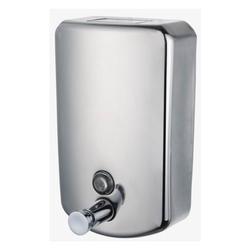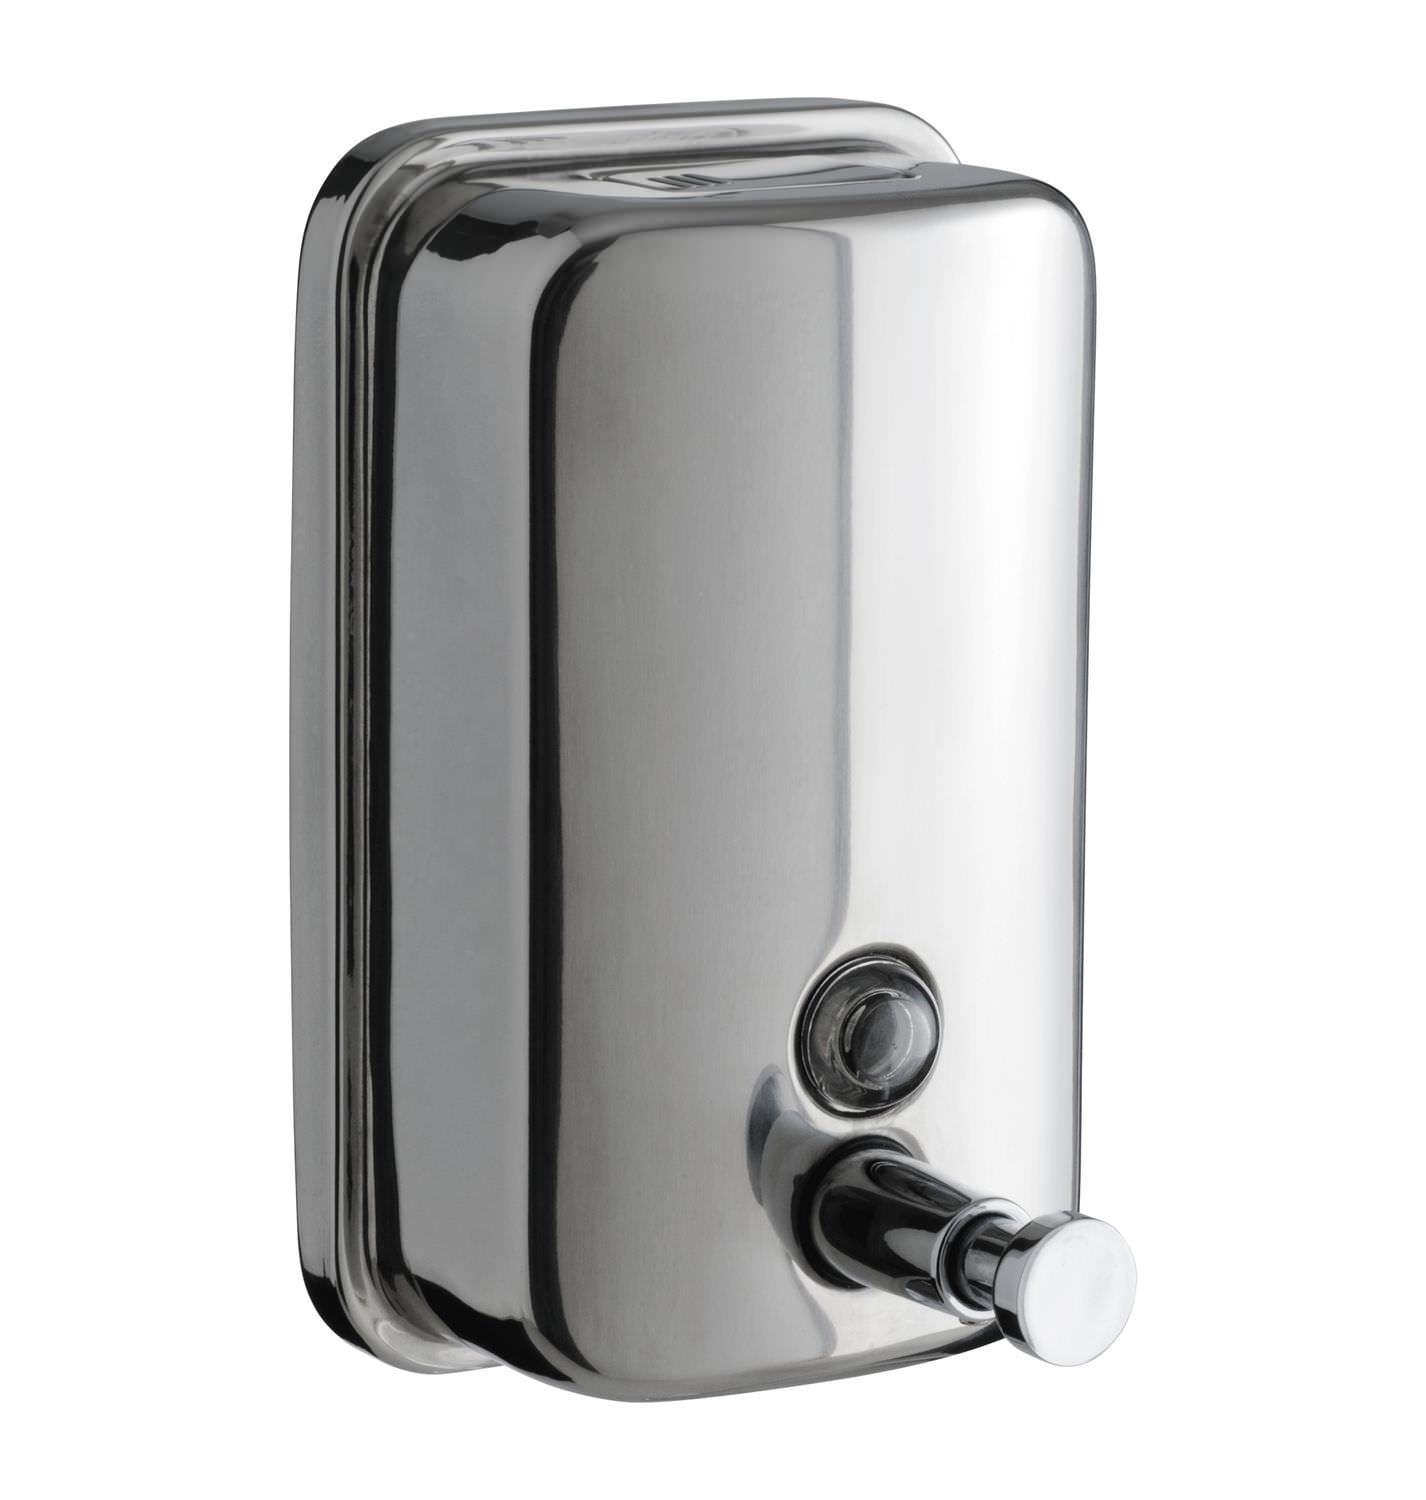The first image is the image on the left, the second image is the image on the right. Analyze the images presented: Is the assertion "The dispenser on the right image is tall and round." valid? Answer yes or no. No. 